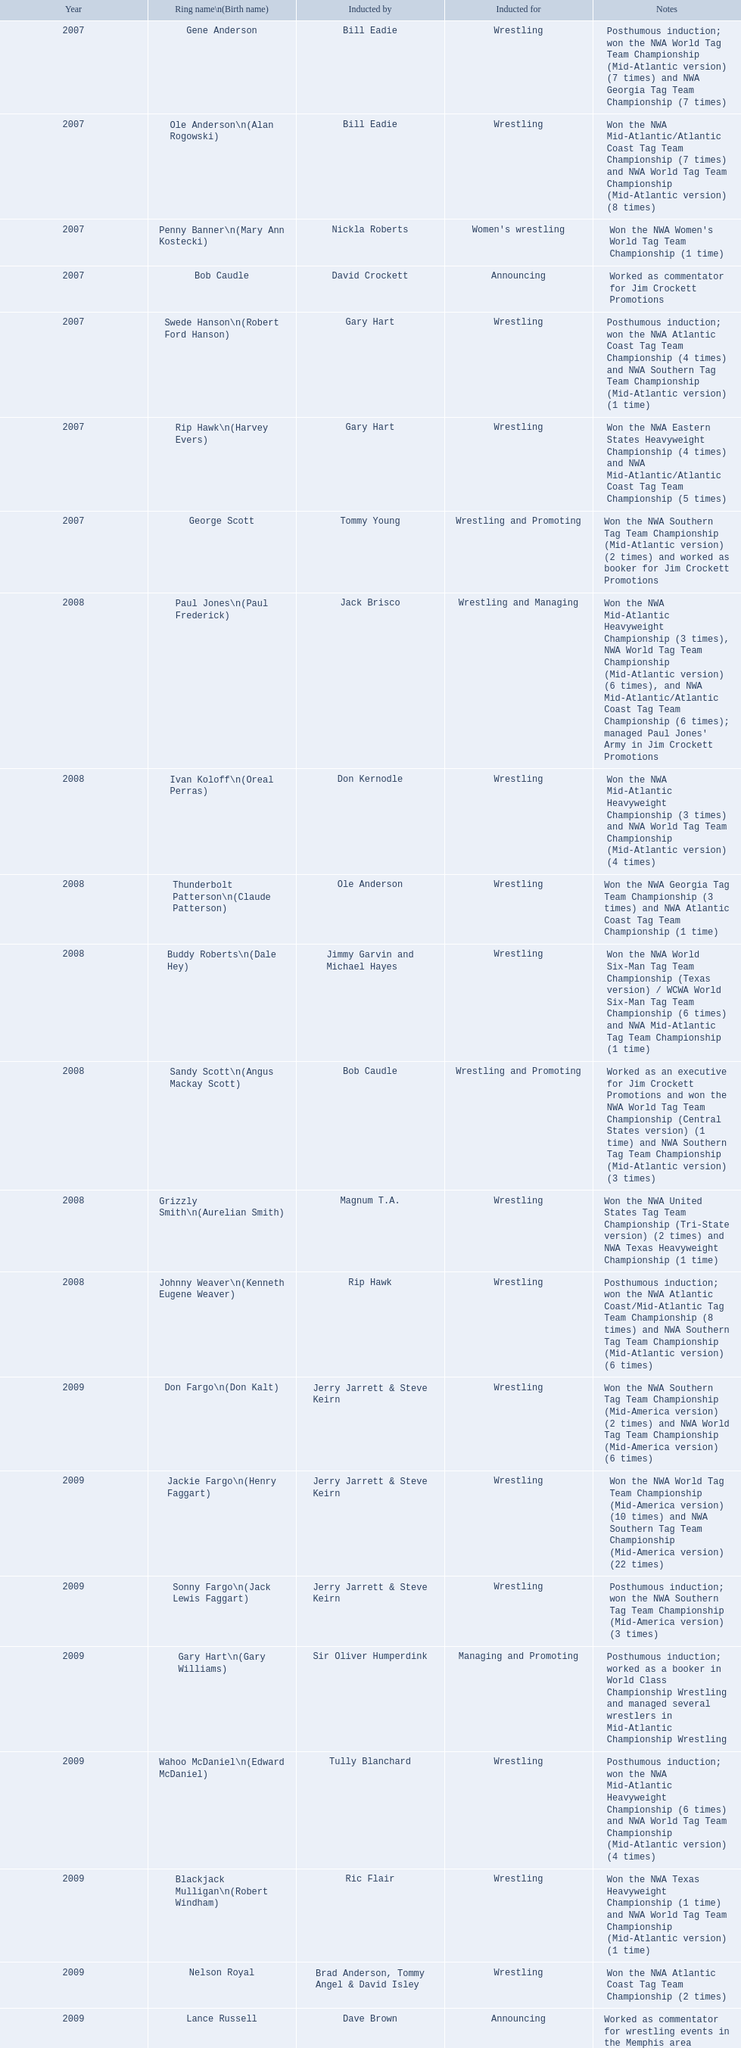Who was the announcer inducted into the hall of champions in 2007? Bob Caudle. Who was the subsequent announcer to be inducted? Lance Russell. 